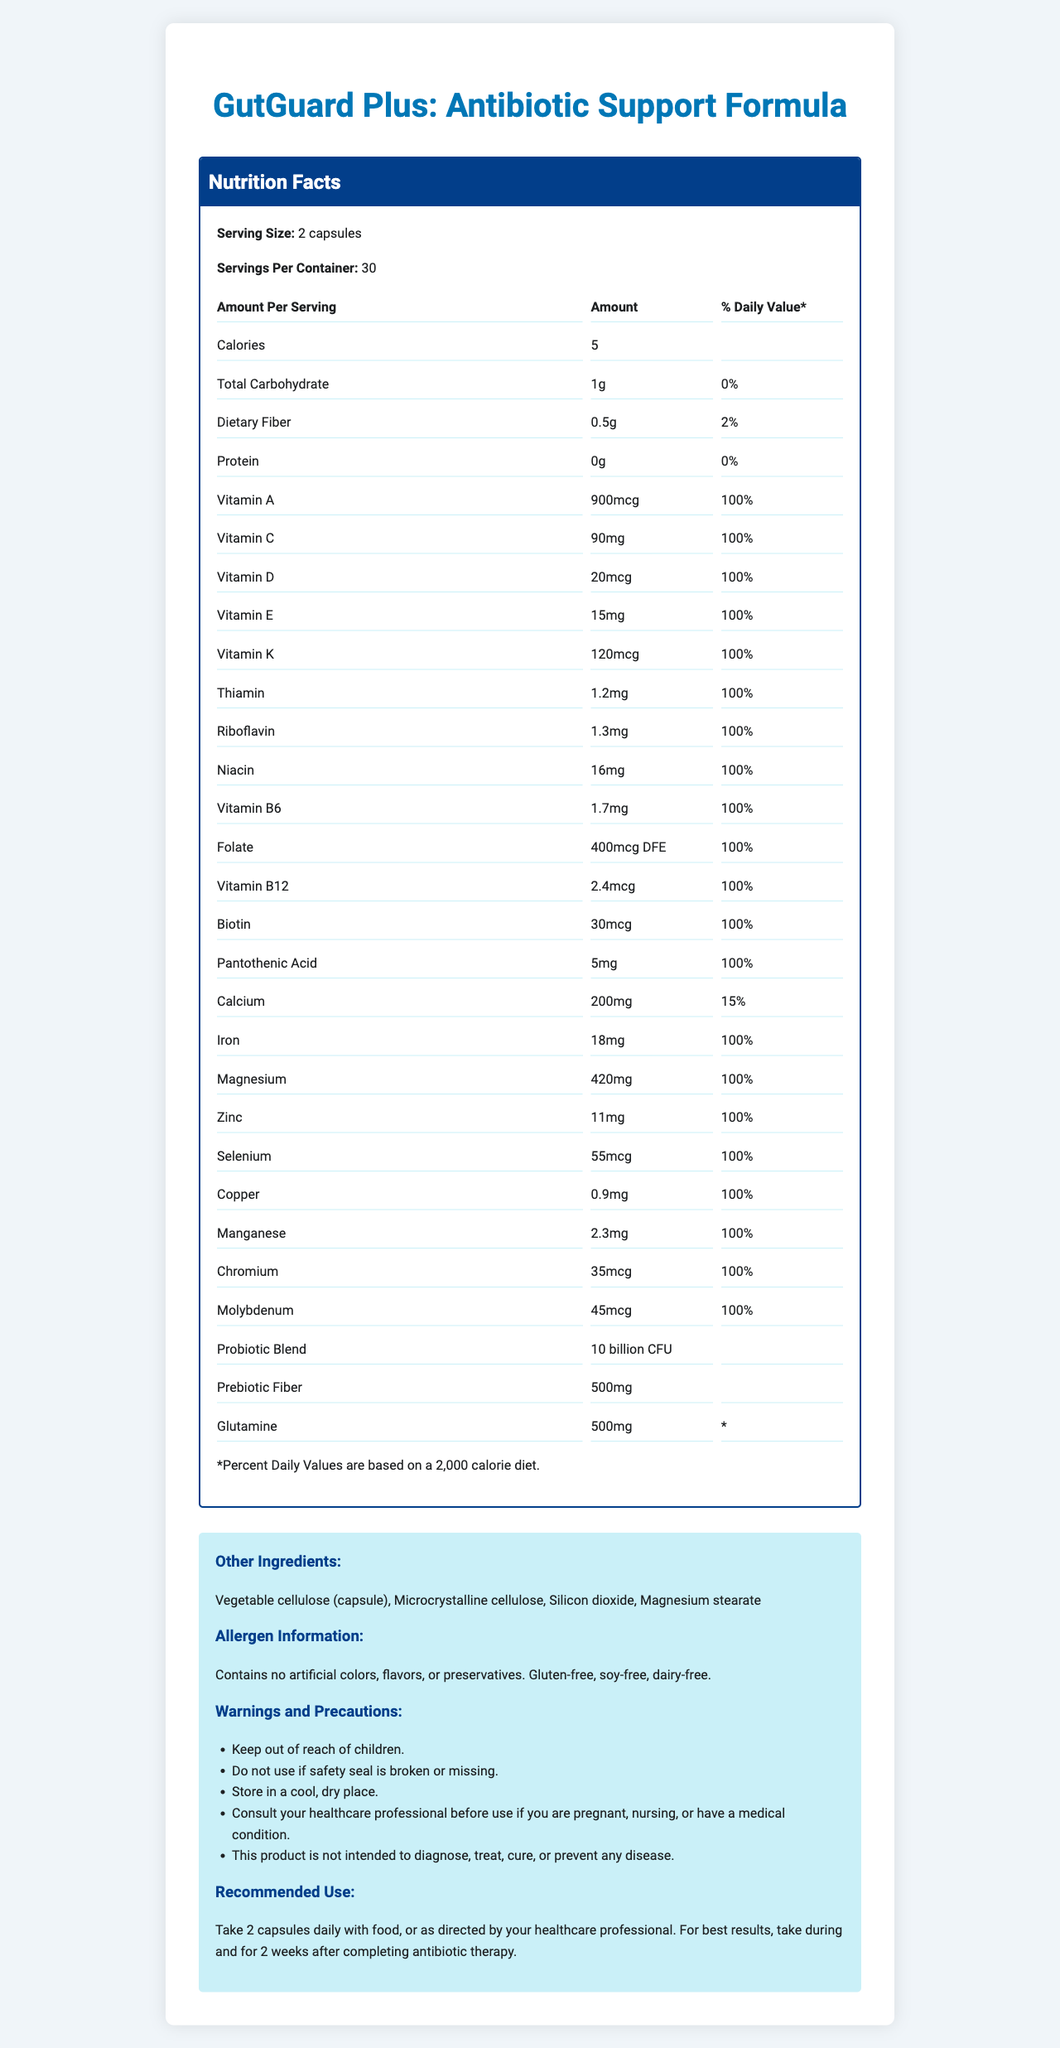what is the serving size? The document states that the serving size is 2 capsules.
Answer: 2 capsules how many servings are there per container? The document mentions that there are 30 servings per container.
Answer: 30 how many calories are there per serving? The document indicates that there are 5 calories per serving.
Answer: 5 what is the amount of dietary fiber per serving? The document states that the amount of dietary fiber per serving is 0.5g.
Answer: 0.5g what percentage of the daily value of vitamin C is provided per serving? The document shows that the daily value percentage of vitamin C per serving is 100%.
Answer: 100% what are the ingredients in the probiotic blend? The document lists these ingredients in the probiotic blend.
Answer: Lactobacillus acidophilus, Bifidobacterium lactis, Lactobacillus rhamnosus which vitamin is present at 900mcg per serving? A. Vitamin A B. Vitamin C C. Vitamin D D. Vitamin K The document indicates that vitamin A is present at 900mcg per serving.
Answer: A which of the following is not an ingredient in the prebiotic fiber? I. Inulin (from chicory root) II. Microcrystalline cellulose III. Silicon dioxide The document lists "Inulin (from chicory root)" as an ingredient in the prebiotic fiber, while microcrystalline cellulose and silicon dioxide are listed under other ingredients.
Answer: II and III is the product gluten-free? The document states under allergen information that the product is gluten-free.
Answer: Yes does this product contain any artificial preservatives? The allergen information specifies that the product contains no artificial colors, flavors, or preservatives.
Answer: No summarize the main idea of the document. The document presents comprehensive details about the nutritional content and usage guidelines for a multivitamin supplement aimed at supporting gut health during antibiotic treatment.
Answer: The document provides detailed nutrition facts and additional information about "GutGuard Plus: Antibiotic Support Formula," a multivitamin supplement designed to support gastrointestinal health during antibiotic therapy. It includes information on serving size, calories, amounts of various vitamins and minerals, probiotic and prebiotic contents, other ingredients, allergen information, warnings, and recommended use. what is the purpose of the product according to the document? The product name and recommended use section suggest that the formula is specifically designed to support gastrointestinal health during and after antibiotic therapy.
Answer: To support gastrointestinal health during antibiotic therapy. where should this supplement be stored? The warnings and precautions section advises storing the product in a cool, dry place.
Answer: In a cool, dry place how long should one continue taking the capsules after completing antibiotic therapy? A. 1 week B. 2 weeks C. 3 weeks D. 1 month According to the recommended use, the capsules should be taken for 2 weeks after completing antibiotic therapy.
Answer: B what is the daily value percentage for calcium per serving? The document lists the daily value percentage for calcium as 15%.
Answer: 15% which ingredient contributes to the product being dairy-free? The allergen information states the product is dairy-free but does not attribute this to a specific ingredient.
Answer: The document does not specify any particular ingredient as contributing to the product being dairy-free, it just states that the product is dairy-free. what is the main ingredient in the capsule shell? The document lists "Vegetable cellulose (capsule)" as an ingredient, indicating it is the main material for the capsule shell.
Answer: Vegetable cellulose how much magnesium is included per serving? The document states that there are 420mg of magnesium per serving.
Answer: 420mg what additional precautions are mentioned for people who are pregnant/nursing or have a medical condition? The warnings and precautions section advises consulting a healthcare professional before using the product if you are pregnant, nursing, or have a medical condition.
Answer: Consult your healthcare professional before use. what are the other ingredients apart from the main vitamins and minerals? The document lists these under the section for other ingredients.
Answer: Vegetable cellulose (capsule), Microcrystalline cellulose, Silicon dioxide, Magnesium stearate does the document provide a specific reason for why probiotics are included in the formula? The document lists the probiotic ingredients and their amounts but does not specify the reason for their inclusion.
Answer: No 